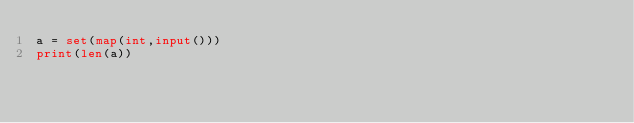Convert code to text. <code><loc_0><loc_0><loc_500><loc_500><_Python_>a = set(map(int,input()))
print(len(a))</code> 